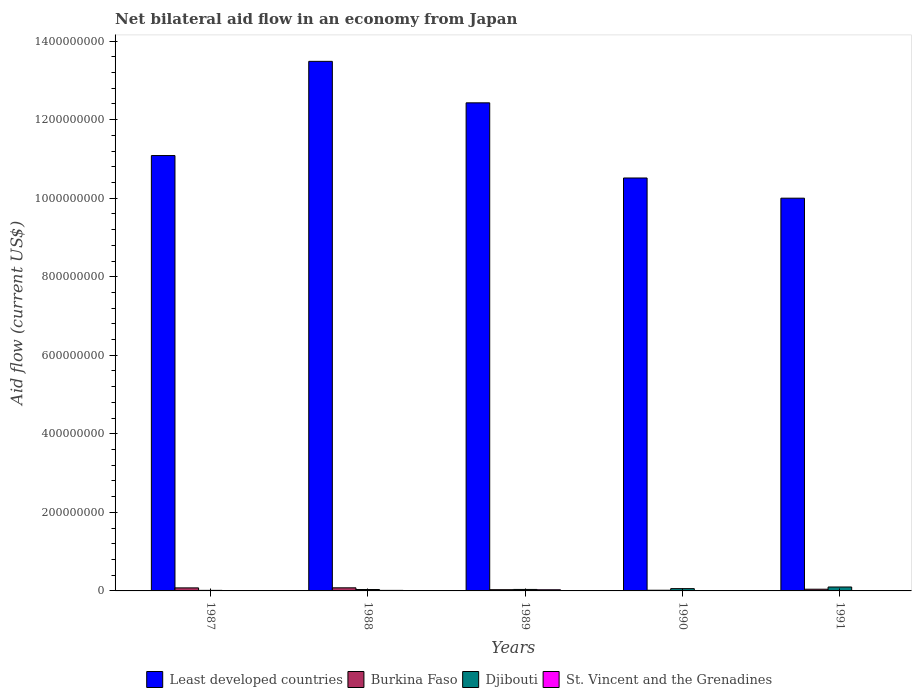How many different coloured bars are there?
Keep it short and to the point. 4. How many groups of bars are there?
Your response must be concise. 5. Are the number of bars on each tick of the X-axis equal?
Your response must be concise. Yes. How many bars are there on the 4th tick from the left?
Make the answer very short. 4. How many bars are there on the 1st tick from the right?
Offer a terse response. 4. In how many cases, is the number of bars for a given year not equal to the number of legend labels?
Make the answer very short. 0. What is the net bilateral aid flow in Djibouti in 1989?
Provide a succinct answer. 3.76e+06. Across all years, what is the maximum net bilateral aid flow in St. Vincent and the Grenadines?
Make the answer very short. 2.97e+06. What is the total net bilateral aid flow in Least developed countries in the graph?
Provide a succinct answer. 5.75e+09. What is the difference between the net bilateral aid flow in Burkina Faso in 1988 and that in 1989?
Your answer should be compact. 4.73e+06. What is the difference between the net bilateral aid flow in St. Vincent and the Grenadines in 1987 and the net bilateral aid flow in Least developed countries in 1991?
Your response must be concise. -1.00e+09. What is the average net bilateral aid flow in Burkina Faso per year?
Provide a succinct answer. 4.97e+06. In the year 1987, what is the difference between the net bilateral aid flow in Burkina Faso and net bilateral aid flow in Djibouti?
Give a very brief answer. 6.29e+06. What is the ratio of the net bilateral aid flow in St. Vincent and the Grenadines in 1987 to that in 1991?
Offer a terse response. 0.19. Is the net bilateral aid flow in Least developed countries in 1987 less than that in 1991?
Offer a terse response. No. Is the difference between the net bilateral aid flow in Burkina Faso in 1987 and 1989 greater than the difference between the net bilateral aid flow in Djibouti in 1987 and 1989?
Offer a terse response. Yes. What is the difference between the highest and the second highest net bilateral aid flow in Djibouti?
Ensure brevity in your answer.  4.18e+06. What is the difference between the highest and the lowest net bilateral aid flow in Djibouti?
Provide a short and direct response. 8.56e+06. Is the sum of the net bilateral aid flow in Burkina Faso in 1987 and 1990 greater than the maximum net bilateral aid flow in Least developed countries across all years?
Make the answer very short. No. What does the 2nd bar from the left in 1987 represents?
Provide a succinct answer. Burkina Faso. What does the 2nd bar from the right in 1989 represents?
Give a very brief answer. Djibouti. How many bars are there?
Keep it short and to the point. 20. How many years are there in the graph?
Offer a very short reply. 5. Are the values on the major ticks of Y-axis written in scientific E-notation?
Provide a succinct answer. No. Where does the legend appear in the graph?
Make the answer very short. Bottom center. How many legend labels are there?
Provide a succinct answer. 4. How are the legend labels stacked?
Ensure brevity in your answer.  Horizontal. What is the title of the graph?
Make the answer very short. Net bilateral aid flow in an economy from Japan. Does "Israel" appear as one of the legend labels in the graph?
Make the answer very short. No. What is the label or title of the X-axis?
Your answer should be compact. Years. What is the Aid flow (current US$) of Least developed countries in 1987?
Give a very brief answer. 1.11e+09. What is the Aid flow (current US$) of Burkina Faso in 1987?
Provide a short and direct response. 7.72e+06. What is the Aid flow (current US$) in Djibouti in 1987?
Your answer should be compact. 1.43e+06. What is the Aid flow (current US$) of St. Vincent and the Grenadines in 1987?
Your response must be concise. 1.70e+05. What is the Aid flow (current US$) of Least developed countries in 1988?
Your answer should be very brief. 1.35e+09. What is the Aid flow (current US$) in Burkina Faso in 1988?
Make the answer very short. 7.89e+06. What is the Aid flow (current US$) of Djibouti in 1988?
Ensure brevity in your answer.  3.57e+06. What is the Aid flow (current US$) of St. Vincent and the Grenadines in 1988?
Your response must be concise. 1.36e+06. What is the Aid flow (current US$) of Least developed countries in 1989?
Your response must be concise. 1.24e+09. What is the Aid flow (current US$) in Burkina Faso in 1989?
Offer a terse response. 3.16e+06. What is the Aid flow (current US$) of Djibouti in 1989?
Your response must be concise. 3.76e+06. What is the Aid flow (current US$) of St. Vincent and the Grenadines in 1989?
Your answer should be very brief. 2.97e+06. What is the Aid flow (current US$) in Least developed countries in 1990?
Your response must be concise. 1.05e+09. What is the Aid flow (current US$) in Burkina Faso in 1990?
Provide a succinct answer. 1.74e+06. What is the Aid flow (current US$) in Djibouti in 1990?
Your response must be concise. 5.81e+06. What is the Aid flow (current US$) in Burkina Faso in 1991?
Keep it short and to the point. 4.35e+06. What is the Aid flow (current US$) of Djibouti in 1991?
Offer a terse response. 9.99e+06. What is the Aid flow (current US$) of St. Vincent and the Grenadines in 1991?
Keep it short and to the point. 8.90e+05. Across all years, what is the maximum Aid flow (current US$) in Least developed countries?
Your answer should be very brief. 1.35e+09. Across all years, what is the maximum Aid flow (current US$) in Burkina Faso?
Keep it short and to the point. 7.89e+06. Across all years, what is the maximum Aid flow (current US$) in Djibouti?
Your answer should be very brief. 9.99e+06. Across all years, what is the maximum Aid flow (current US$) of St. Vincent and the Grenadines?
Keep it short and to the point. 2.97e+06. Across all years, what is the minimum Aid flow (current US$) in Least developed countries?
Your answer should be very brief. 1.00e+09. Across all years, what is the minimum Aid flow (current US$) in Burkina Faso?
Offer a very short reply. 1.74e+06. Across all years, what is the minimum Aid flow (current US$) of Djibouti?
Provide a succinct answer. 1.43e+06. Across all years, what is the minimum Aid flow (current US$) in St. Vincent and the Grenadines?
Give a very brief answer. 1.70e+05. What is the total Aid flow (current US$) of Least developed countries in the graph?
Offer a very short reply. 5.75e+09. What is the total Aid flow (current US$) of Burkina Faso in the graph?
Provide a succinct answer. 2.49e+07. What is the total Aid flow (current US$) in Djibouti in the graph?
Ensure brevity in your answer.  2.46e+07. What is the total Aid flow (current US$) in St. Vincent and the Grenadines in the graph?
Make the answer very short. 6.19e+06. What is the difference between the Aid flow (current US$) of Least developed countries in 1987 and that in 1988?
Offer a terse response. -2.40e+08. What is the difference between the Aid flow (current US$) in Djibouti in 1987 and that in 1988?
Your response must be concise. -2.14e+06. What is the difference between the Aid flow (current US$) in St. Vincent and the Grenadines in 1987 and that in 1988?
Offer a very short reply. -1.19e+06. What is the difference between the Aid flow (current US$) of Least developed countries in 1987 and that in 1989?
Provide a succinct answer. -1.34e+08. What is the difference between the Aid flow (current US$) in Burkina Faso in 1987 and that in 1989?
Make the answer very short. 4.56e+06. What is the difference between the Aid flow (current US$) of Djibouti in 1987 and that in 1989?
Your response must be concise. -2.33e+06. What is the difference between the Aid flow (current US$) of St. Vincent and the Grenadines in 1987 and that in 1989?
Your response must be concise. -2.80e+06. What is the difference between the Aid flow (current US$) in Least developed countries in 1987 and that in 1990?
Your answer should be compact. 5.71e+07. What is the difference between the Aid flow (current US$) in Burkina Faso in 1987 and that in 1990?
Offer a very short reply. 5.98e+06. What is the difference between the Aid flow (current US$) of Djibouti in 1987 and that in 1990?
Make the answer very short. -4.38e+06. What is the difference between the Aid flow (current US$) of St. Vincent and the Grenadines in 1987 and that in 1990?
Provide a short and direct response. -6.30e+05. What is the difference between the Aid flow (current US$) in Least developed countries in 1987 and that in 1991?
Offer a terse response. 1.09e+08. What is the difference between the Aid flow (current US$) in Burkina Faso in 1987 and that in 1991?
Offer a terse response. 3.37e+06. What is the difference between the Aid flow (current US$) in Djibouti in 1987 and that in 1991?
Keep it short and to the point. -8.56e+06. What is the difference between the Aid flow (current US$) in St. Vincent and the Grenadines in 1987 and that in 1991?
Your response must be concise. -7.20e+05. What is the difference between the Aid flow (current US$) of Least developed countries in 1988 and that in 1989?
Your response must be concise. 1.06e+08. What is the difference between the Aid flow (current US$) in Burkina Faso in 1988 and that in 1989?
Your answer should be compact. 4.73e+06. What is the difference between the Aid flow (current US$) of Djibouti in 1988 and that in 1989?
Give a very brief answer. -1.90e+05. What is the difference between the Aid flow (current US$) in St. Vincent and the Grenadines in 1988 and that in 1989?
Give a very brief answer. -1.61e+06. What is the difference between the Aid flow (current US$) in Least developed countries in 1988 and that in 1990?
Ensure brevity in your answer.  2.97e+08. What is the difference between the Aid flow (current US$) in Burkina Faso in 1988 and that in 1990?
Your answer should be compact. 6.15e+06. What is the difference between the Aid flow (current US$) of Djibouti in 1988 and that in 1990?
Ensure brevity in your answer.  -2.24e+06. What is the difference between the Aid flow (current US$) in St. Vincent and the Grenadines in 1988 and that in 1990?
Offer a terse response. 5.60e+05. What is the difference between the Aid flow (current US$) in Least developed countries in 1988 and that in 1991?
Offer a terse response. 3.48e+08. What is the difference between the Aid flow (current US$) in Burkina Faso in 1988 and that in 1991?
Make the answer very short. 3.54e+06. What is the difference between the Aid flow (current US$) of Djibouti in 1988 and that in 1991?
Make the answer very short. -6.42e+06. What is the difference between the Aid flow (current US$) of St. Vincent and the Grenadines in 1988 and that in 1991?
Your response must be concise. 4.70e+05. What is the difference between the Aid flow (current US$) in Least developed countries in 1989 and that in 1990?
Ensure brevity in your answer.  1.91e+08. What is the difference between the Aid flow (current US$) in Burkina Faso in 1989 and that in 1990?
Offer a very short reply. 1.42e+06. What is the difference between the Aid flow (current US$) of Djibouti in 1989 and that in 1990?
Your answer should be compact. -2.05e+06. What is the difference between the Aid flow (current US$) of St. Vincent and the Grenadines in 1989 and that in 1990?
Keep it short and to the point. 2.17e+06. What is the difference between the Aid flow (current US$) of Least developed countries in 1989 and that in 1991?
Give a very brief answer. 2.43e+08. What is the difference between the Aid flow (current US$) in Burkina Faso in 1989 and that in 1991?
Your response must be concise. -1.19e+06. What is the difference between the Aid flow (current US$) in Djibouti in 1989 and that in 1991?
Offer a terse response. -6.23e+06. What is the difference between the Aid flow (current US$) of St. Vincent and the Grenadines in 1989 and that in 1991?
Offer a terse response. 2.08e+06. What is the difference between the Aid flow (current US$) of Least developed countries in 1990 and that in 1991?
Your response must be concise. 5.14e+07. What is the difference between the Aid flow (current US$) in Burkina Faso in 1990 and that in 1991?
Keep it short and to the point. -2.61e+06. What is the difference between the Aid flow (current US$) in Djibouti in 1990 and that in 1991?
Keep it short and to the point. -4.18e+06. What is the difference between the Aid flow (current US$) of St. Vincent and the Grenadines in 1990 and that in 1991?
Offer a terse response. -9.00e+04. What is the difference between the Aid flow (current US$) in Least developed countries in 1987 and the Aid flow (current US$) in Burkina Faso in 1988?
Keep it short and to the point. 1.10e+09. What is the difference between the Aid flow (current US$) of Least developed countries in 1987 and the Aid flow (current US$) of Djibouti in 1988?
Your response must be concise. 1.10e+09. What is the difference between the Aid flow (current US$) of Least developed countries in 1987 and the Aid flow (current US$) of St. Vincent and the Grenadines in 1988?
Your response must be concise. 1.11e+09. What is the difference between the Aid flow (current US$) of Burkina Faso in 1987 and the Aid flow (current US$) of Djibouti in 1988?
Keep it short and to the point. 4.15e+06. What is the difference between the Aid flow (current US$) in Burkina Faso in 1987 and the Aid flow (current US$) in St. Vincent and the Grenadines in 1988?
Provide a short and direct response. 6.36e+06. What is the difference between the Aid flow (current US$) of Least developed countries in 1987 and the Aid flow (current US$) of Burkina Faso in 1989?
Keep it short and to the point. 1.11e+09. What is the difference between the Aid flow (current US$) in Least developed countries in 1987 and the Aid flow (current US$) in Djibouti in 1989?
Give a very brief answer. 1.10e+09. What is the difference between the Aid flow (current US$) in Least developed countries in 1987 and the Aid flow (current US$) in St. Vincent and the Grenadines in 1989?
Keep it short and to the point. 1.11e+09. What is the difference between the Aid flow (current US$) in Burkina Faso in 1987 and the Aid flow (current US$) in Djibouti in 1989?
Your answer should be very brief. 3.96e+06. What is the difference between the Aid flow (current US$) in Burkina Faso in 1987 and the Aid flow (current US$) in St. Vincent and the Grenadines in 1989?
Offer a very short reply. 4.75e+06. What is the difference between the Aid flow (current US$) of Djibouti in 1987 and the Aid flow (current US$) of St. Vincent and the Grenadines in 1989?
Provide a succinct answer. -1.54e+06. What is the difference between the Aid flow (current US$) in Least developed countries in 1987 and the Aid flow (current US$) in Burkina Faso in 1990?
Keep it short and to the point. 1.11e+09. What is the difference between the Aid flow (current US$) in Least developed countries in 1987 and the Aid flow (current US$) in Djibouti in 1990?
Keep it short and to the point. 1.10e+09. What is the difference between the Aid flow (current US$) of Least developed countries in 1987 and the Aid flow (current US$) of St. Vincent and the Grenadines in 1990?
Your answer should be very brief. 1.11e+09. What is the difference between the Aid flow (current US$) in Burkina Faso in 1987 and the Aid flow (current US$) in Djibouti in 1990?
Provide a succinct answer. 1.91e+06. What is the difference between the Aid flow (current US$) of Burkina Faso in 1987 and the Aid flow (current US$) of St. Vincent and the Grenadines in 1990?
Ensure brevity in your answer.  6.92e+06. What is the difference between the Aid flow (current US$) in Djibouti in 1987 and the Aid flow (current US$) in St. Vincent and the Grenadines in 1990?
Offer a terse response. 6.30e+05. What is the difference between the Aid flow (current US$) in Least developed countries in 1987 and the Aid flow (current US$) in Burkina Faso in 1991?
Provide a succinct answer. 1.10e+09. What is the difference between the Aid flow (current US$) of Least developed countries in 1987 and the Aid flow (current US$) of Djibouti in 1991?
Offer a terse response. 1.10e+09. What is the difference between the Aid flow (current US$) of Least developed countries in 1987 and the Aid flow (current US$) of St. Vincent and the Grenadines in 1991?
Ensure brevity in your answer.  1.11e+09. What is the difference between the Aid flow (current US$) in Burkina Faso in 1987 and the Aid flow (current US$) in Djibouti in 1991?
Keep it short and to the point. -2.27e+06. What is the difference between the Aid flow (current US$) of Burkina Faso in 1987 and the Aid flow (current US$) of St. Vincent and the Grenadines in 1991?
Your answer should be very brief. 6.83e+06. What is the difference between the Aid flow (current US$) in Djibouti in 1987 and the Aid flow (current US$) in St. Vincent and the Grenadines in 1991?
Your answer should be very brief. 5.40e+05. What is the difference between the Aid flow (current US$) in Least developed countries in 1988 and the Aid flow (current US$) in Burkina Faso in 1989?
Ensure brevity in your answer.  1.35e+09. What is the difference between the Aid flow (current US$) of Least developed countries in 1988 and the Aid flow (current US$) of Djibouti in 1989?
Keep it short and to the point. 1.34e+09. What is the difference between the Aid flow (current US$) of Least developed countries in 1988 and the Aid flow (current US$) of St. Vincent and the Grenadines in 1989?
Provide a succinct answer. 1.35e+09. What is the difference between the Aid flow (current US$) of Burkina Faso in 1988 and the Aid flow (current US$) of Djibouti in 1989?
Provide a succinct answer. 4.13e+06. What is the difference between the Aid flow (current US$) in Burkina Faso in 1988 and the Aid flow (current US$) in St. Vincent and the Grenadines in 1989?
Provide a succinct answer. 4.92e+06. What is the difference between the Aid flow (current US$) of Least developed countries in 1988 and the Aid flow (current US$) of Burkina Faso in 1990?
Keep it short and to the point. 1.35e+09. What is the difference between the Aid flow (current US$) in Least developed countries in 1988 and the Aid flow (current US$) in Djibouti in 1990?
Provide a succinct answer. 1.34e+09. What is the difference between the Aid flow (current US$) of Least developed countries in 1988 and the Aid flow (current US$) of St. Vincent and the Grenadines in 1990?
Offer a terse response. 1.35e+09. What is the difference between the Aid flow (current US$) of Burkina Faso in 1988 and the Aid flow (current US$) of Djibouti in 1990?
Keep it short and to the point. 2.08e+06. What is the difference between the Aid flow (current US$) in Burkina Faso in 1988 and the Aid flow (current US$) in St. Vincent and the Grenadines in 1990?
Your response must be concise. 7.09e+06. What is the difference between the Aid flow (current US$) of Djibouti in 1988 and the Aid flow (current US$) of St. Vincent and the Grenadines in 1990?
Provide a succinct answer. 2.77e+06. What is the difference between the Aid flow (current US$) in Least developed countries in 1988 and the Aid flow (current US$) in Burkina Faso in 1991?
Your answer should be compact. 1.34e+09. What is the difference between the Aid flow (current US$) of Least developed countries in 1988 and the Aid flow (current US$) of Djibouti in 1991?
Offer a terse response. 1.34e+09. What is the difference between the Aid flow (current US$) in Least developed countries in 1988 and the Aid flow (current US$) in St. Vincent and the Grenadines in 1991?
Your response must be concise. 1.35e+09. What is the difference between the Aid flow (current US$) of Burkina Faso in 1988 and the Aid flow (current US$) of Djibouti in 1991?
Your response must be concise. -2.10e+06. What is the difference between the Aid flow (current US$) of Djibouti in 1988 and the Aid flow (current US$) of St. Vincent and the Grenadines in 1991?
Keep it short and to the point. 2.68e+06. What is the difference between the Aid flow (current US$) in Least developed countries in 1989 and the Aid flow (current US$) in Burkina Faso in 1990?
Make the answer very short. 1.24e+09. What is the difference between the Aid flow (current US$) in Least developed countries in 1989 and the Aid flow (current US$) in Djibouti in 1990?
Offer a very short reply. 1.24e+09. What is the difference between the Aid flow (current US$) in Least developed countries in 1989 and the Aid flow (current US$) in St. Vincent and the Grenadines in 1990?
Offer a terse response. 1.24e+09. What is the difference between the Aid flow (current US$) in Burkina Faso in 1989 and the Aid flow (current US$) in Djibouti in 1990?
Keep it short and to the point. -2.65e+06. What is the difference between the Aid flow (current US$) of Burkina Faso in 1989 and the Aid flow (current US$) of St. Vincent and the Grenadines in 1990?
Ensure brevity in your answer.  2.36e+06. What is the difference between the Aid flow (current US$) in Djibouti in 1989 and the Aid flow (current US$) in St. Vincent and the Grenadines in 1990?
Give a very brief answer. 2.96e+06. What is the difference between the Aid flow (current US$) of Least developed countries in 1989 and the Aid flow (current US$) of Burkina Faso in 1991?
Your answer should be compact. 1.24e+09. What is the difference between the Aid flow (current US$) in Least developed countries in 1989 and the Aid flow (current US$) in Djibouti in 1991?
Offer a very short reply. 1.23e+09. What is the difference between the Aid flow (current US$) in Least developed countries in 1989 and the Aid flow (current US$) in St. Vincent and the Grenadines in 1991?
Give a very brief answer. 1.24e+09. What is the difference between the Aid flow (current US$) of Burkina Faso in 1989 and the Aid flow (current US$) of Djibouti in 1991?
Your answer should be very brief. -6.83e+06. What is the difference between the Aid flow (current US$) of Burkina Faso in 1989 and the Aid flow (current US$) of St. Vincent and the Grenadines in 1991?
Offer a very short reply. 2.27e+06. What is the difference between the Aid flow (current US$) of Djibouti in 1989 and the Aid flow (current US$) of St. Vincent and the Grenadines in 1991?
Provide a succinct answer. 2.87e+06. What is the difference between the Aid flow (current US$) of Least developed countries in 1990 and the Aid flow (current US$) of Burkina Faso in 1991?
Keep it short and to the point. 1.05e+09. What is the difference between the Aid flow (current US$) of Least developed countries in 1990 and the Aid flow (current US$) of Djibouti in 1991?
Give a very brief answer. 1.04e+09. What is the difference between the Aid flow (current US$) in Least developed countries in 1990 and the Aid flow (current US$) in St. Vincent and the Grenadines in 1991?
Give a very brief answer. 1.05e+09. What is the difference between the Aid flow (current US$) of Burkina Faso in 1990 and the Aid flow (current US$) of Djibouti in 1991?
Ensure brevity in your answer.  -8.25e+06. What is the difference between the Aid flow (current US$) of Burkina Faso in 1990 and the Aid flow (current US$) of St. Vincent and the Grenadines in 1991?
Offer a very short reply. 8.50e+05. What is the difference between the Aid flow (current US$) in Djibouti in 1990 and the Aid flow (current US$) in St. Vincent and the Grenadines in 1991?
Keep it short and to the point. 4.92e+06. What is the average Aid flow (current US$) of Least developed countries per year?
Offer a very short reply. 1.15e+09. What is the average Aid flow (current US$) of Burkina Faso per year?
Offer a terse response. 4.97e+06. What is the average Aid flow (current US$) of Djibouti per year?
Make the answer very short. 4.91e+06. What is the average Aid flow (current US$) of St. Vincent and the Grenadines per year?
Keep it short and to the point. 1.24e+06. In the year 1987, what is the difference between the Aid flow (current US$) in Least developed countries and Aid flow (current US$) in Burkina Faso?
Keep it short and to the point. 1.10e+09. In the year 1987, what is the difference between the Aid flow (current US$) in Least developed countries and Aid flow (current US$) in Djibouti?
Offer a very short reply. 1.11e+09. In the year 1987, what is the difference between the Aid flow (current US$) in Least developed countries and Aid flow (current US$) in St. Vincent and the Grenadines?
Offer a terse response. 1.11e+09. In the year 1987, what is the difference between the Aid flow (current US$) in Burkina Faso and Aid flow (current US$) in Djibouti?
Your answer should be compact. 6.29e+06. In the year 1987, what is the difference between the Aid flow (current US$) in Burkina Faso and Aid flow (current US$) in St. Vincent and the Grenadines?
Offer a very short reply. 7.55e+06. In the year 1987, what is the difference between the Aid flow (current US$) in Djibouti and Aid flow (current US$) in St. Vincent and the Grenadines?
Provide a short and direct response. 1.26e+06. In the year 1988, what is the difference between the Aid flow (current US$) of Least developed countries and Aid flow (current US$) of Burkina Faso?
Offer a terse response. 1.34e+09. In the year 1988, what is the difference between the Aid flow (current US$) in Least developed countries and Aid flow (current US$) in Djibouti?
Your answer should be compact. 1.34e+09. In the year 1988, what is the difference between the Aid flow (current US$) of Least developed countries and Aid flow (current US$) of St. Vincent and the Grenadines?
Your answer should be very brief. 1.35e+09. In the year 1988, what is the difference between the Aid flow (current US$) in Burkina Faso and Aid flow (current US$) in Djibouti?
Offer a terse response. 4.32e+06. In the year 1988, what is the difference between the Aid flow (current US$) of Burkina Faso and Aid flow (current US$) of St. Vincent and the Grenadines?
Ensure brevity in your answer.  6.53e+06. In the year 1988, what is the difference between the Aid flow (current US$) of Djibouti and Aid flow (current US$) of St. Vincent and the Grenadines?
Offer a very short reply. 2.21e+06. In the year 1989, what is the difference between the Aid flow (current US$) in Least developed countries and Aid flow (current US$) in Burkina Faso?
Your answer should be compact. 1.24e+09. In the year 1989, what is the difference between the Aid flow (current US$) of Least developed countries and Aid flow (current US$) of Djibouti?
Give a very brief answer. 1.24e+09. In the year 1989, what is the difference between the Aid flow (current US$) of Least developed countries and Aid flow (current US$) of St. Vincent and the Grenadines?
Ensure brevity in your answer.  1.24e+09. In the year 1989, what is the difference between the Aid flow (current US$) in Burkina Faso and Aid flow (current US$) in Djibouti?
Your answer should be very brief. -6.00e+05. In the year 1989, what is the difference between the Aid flow (current US$) of Burkina Faso and Aid flow (current US$) of St. Vincent and the Grenadines?
Make the answer very short. 1.90e+05. In the year 1989, what is the difference between the Aid flow (current US$) of Djibouti and Aid flow (current US$) of St. Vincent and the Grenadines?
Your answer should be very brief. 7.90e+05. In the year 1990, what is the difference between the Aid flow (current US$) of Least developed countries and Aid flow (current US$) of Burkina Faso?
Ensure brevity in your answer.  1.05e+09. In the year 1990, what is the difference between the Aid flow (current US$) of Least developed countries and Aid flow (current US$) of Djibouti?
Your response must be concise. 1.05e+09. In the year 1990, what is the difference between the Aid flow (current US$) of Least developed countries and Aid flow (current US$) of St. Vincent and the Grenadines?
Provide a succinct answer. 1.05e+09. In the year 1990, what is the difference between the Aid flow (current US$) of Burkina Faso and Aid flow (current US$) of Djibouti?
Give a very brief answer. -4.07e+06. In the year 1990, what is the difference between the Aid flow (current US$) in Burkina Faso and Aid flow (current US$) in St. Vincent and the Grenadines?
Provide a short and direct response. 9.40e+05. In the year 1990, what is the difference between the Aid flow (current US$) in Djibouti and Aid flow (current US$) in St. Vincent and the Grenadines?
Provide a short and direct response. 5.01e+06. In the year 1991, what is the difference between the Aid flow (current US$) in Least developed countries and Aid flow (current US$) in Burkina Faso?
Your answer should be very brief. 9.96e+08. In the year 1991, what is the difference between the Aid flow (current US$) of Least developed countries and Aid flow (current US$) of Djibouti?
Give a very brief answer. 9.90e+08. In the year 1991, what is the difference between the Aid flow (current US$) in Least developed countries and Aid flow (current US$) in St. Vincent and the Grenadines?
Make the answer very short. 9.99e+08. In the year 1991, what is the difference between the Aid flow (current US$) in Burkina Faso and Aid flow (current US$) in Djibouti?
Your answer should be compact. -5.64e+06. In the year 1991, what is the difference between the Aid flow (current US$) of Burkina Faso and Aid flow (current US$) of St. Vincent and the Grenadines?
Keep it short and to the point. 3.46e+06. In the year 1991, what is the difference between the Aid flow (current US$) of Djibouti and Aid flow (current US$) of St. Vincent and the Grenadines?
Offer a terse response. 9.10e+06. What is the ratio of the Aid flow (current US$) of Least developed countries in 1987 to that in 1988?
Your answer should be very brief. 0.82. What is the ratio of the Aid flow (current US$) in Burkina Faso in 1987 to that in 1988?
Give a very brief answer. 0.98. What is the ratio of the Aid flow (current US$) of Djibouti in 1987 to that in 1988?
Offer a terse response. 0.4. What is the ratio of the Aid flow (current US$) in St. Vincent and the Grenadines in 1987 to that in 1988?
Provide a short and direct response. 0.12. What is the ratio of the Aid flow (current US$) of Least developed countries in 1987 to that in 1989?
Your answer should be very brief. 0.89. What is the ratio of the Aid flow (current US$) in Burkina Faso in 1987 to that in 1989?
Provide a short and direct response. 2.44. What is the ratio of the Aid flow (current US$) of Djibouti in 1987 to that in 1989?
Provide a succinct answer. 0.38. What is the ratio of the Aid flow (current US$) in St. Vincent and the Grenadines in 1987 to that in 1989?
Keep it short and to the point. 0.06. What is the ratio of the Aid flow (current US$) in Least developed countries in 1987 to that in 1990?
Offer a terse response. 1.05. What is the ratio of the Aid flow (current US$) in Burkina Faso in 1987 to that in 1990?
Make the answer very short. 4.44. What is the ratio of the Aid flow (current US$) of Djibouti in 1987 to that in 1990?
Your response must be concise. 0.25. What is the ratio of the Aid flow (current US$) of St. Vincent and the Grenadines in 1987 to that in 1990?
Offer a very short reply. 0.21. What is the ratio of the Aid flow (current US$) in Least developed countries in 1987 to that in 1991?
Provide a short and direct response. 1.11. What is the ratio of the Aid flow (current US$) of Burkina Faso in 1987 to that in 1991?
Offer a terse response. 1.77. What is the ratio of the Aid flow (current US$) of Djibouti in 1987 to that in 1991?
Your response must be concise. 0.14. What is the ratio of the Aid flow (current US$) in St. Vincent and the Grenadines in 1987 to that in 1991?
Ensure brevity in your answer.  0.19. What is the ratio of the Aid flow (current US$) of Least developed countries in 1988 to that in 1989?
Make the answer very short. 1.08. What is the ratio of the Aid flow (current US$) in Burkina Faso in 1988 to that in 1989?
Provide a short and direct response. 2.5. What is the ratio of the Aid flow (current US$) in Djibouti in 1988 to that in 1989?
Offer a terse response. 0.95. What is the ratio of the Aid flow (current US$) in St. Vincent and the Grenadines in 1988 to that in 1989?
Your response must be concise. 0.46. What is the ratio of the Aid flow (current US$) of Least developed countries in 1988 to that in 1990?
Keep it short and to the point. 1.28. What is the ratio of the Aid flow (current US$) of Burkina Faso in 1988 to that in 1990?
Ensure brevity in your answer.  4.53. What is the ratio of the Aid flow (current US$) in Djibouti in 1988 to that in 1990?
Your answer should be compact. 0.61. What is the ratio of the Aid flow (current US$) of Least developed countries in 1988 to that in 1991?
Offer a very short reply. 1.35. What is the ratio of the Aid flow (current US$) in Burkina Faso in 1988 to that in 1991?
Provide a short and direct response. 1.81. What is the ratio of the Aid flow (current US$) in Djibouti in 1988 to that in 1991?
Your answer should be compact. 0.36. What is the ratio of the Aid flow (current US$) of St. Vincent and the Grenadines in 1988 to that in 1991?
Ensure brevity in your answer.  1.53. What is the ratio of the Aid flow (current US$) of Least developed countries in 1989 to that in 1990?
Ensure brevity in your answer.  1.18. What is the ratio of the Aid flow (current US$) in Burkina Faso in 1989 to that in 1990?
Ensure brevity in your answer.  1.82. What is the ratio of the Aid flow (current US$) in Djibouti in 1989 to that in 1990?
Provide a short and direct response. 0.65. What is the ratio of the Aid flow (current US$) in St. Vincent and the Grenadines in 1989 to that in 1990?
Offer a very short reply. 3.71. What is the ratio of the Aid flow (current US$) of Least developed countries in 1989 to that in 1991?
Ensure brevity in your answer.  1.24. What is the ratio of the Aid flow (current US$) in Burkina Faso in 1989 to that in 1991?
Your answer should be very brief. 0.73. What is the ratio of the Aid flow (current US$) in Djibouti in 1989 to that in 1991?
Give a very brief answer. 0.38. What is the ratio of the Aid flow (current US$) in St. Vincent and the Grenadines in 1989 to that in 1991?
Keep it short and to the point. 3.34. What is the ratio of the Aid flow (current US$) in Least developed countries in 1990 to that in 1991?
Your answer should be very brief. 1.05. What is the ratio of the Aid flow (current US$) of Djibouti in 1990 to that in 1991?
Your response must be concise. 0.58. What is the ratio of the Aid flow (current US$) in St. Vincent and the Grenadines in 1990 to that in 1991?
Provide a short and direct response. 0.9. What is the difference between the highest and the second highest Aid flow (current US$) in Least developed countries?
Provide a succinct answer. 1.06e+08. What is the difference between the highest and the second highest Aid flow (current US$) in Burkina Faso?
Offer a very short reply. 1.70e+05. What is the difference between the highest and the second highest Aid flow (current US$) of Djibouti?
Offer a terse response. 4.18e+06. What is the difference between the highest and the second highest Aid flow (current US$) in St. Vincent and the Grenadines?
Offer a terse response. 1.61e+06. What is the difference between the highest and the lowest Aid flow (current US$) in Least developed countries?
Make the answer very short. 3.48e+08. What is the difference between the highest and the lowest Aid flow (current US$) of Burkina Faso?
Your answer should be compact. 6.15e+06. What is the difference between the highest and the lowest Aid flow (current US$) of Djibouti?
Offer a very short reply. 8.56e+06. What is the difference between the highest and the lowest Aid flow (current US$) in St. Vincent and the Grenadines?
Your answer should be compact. 2.80e+06. 